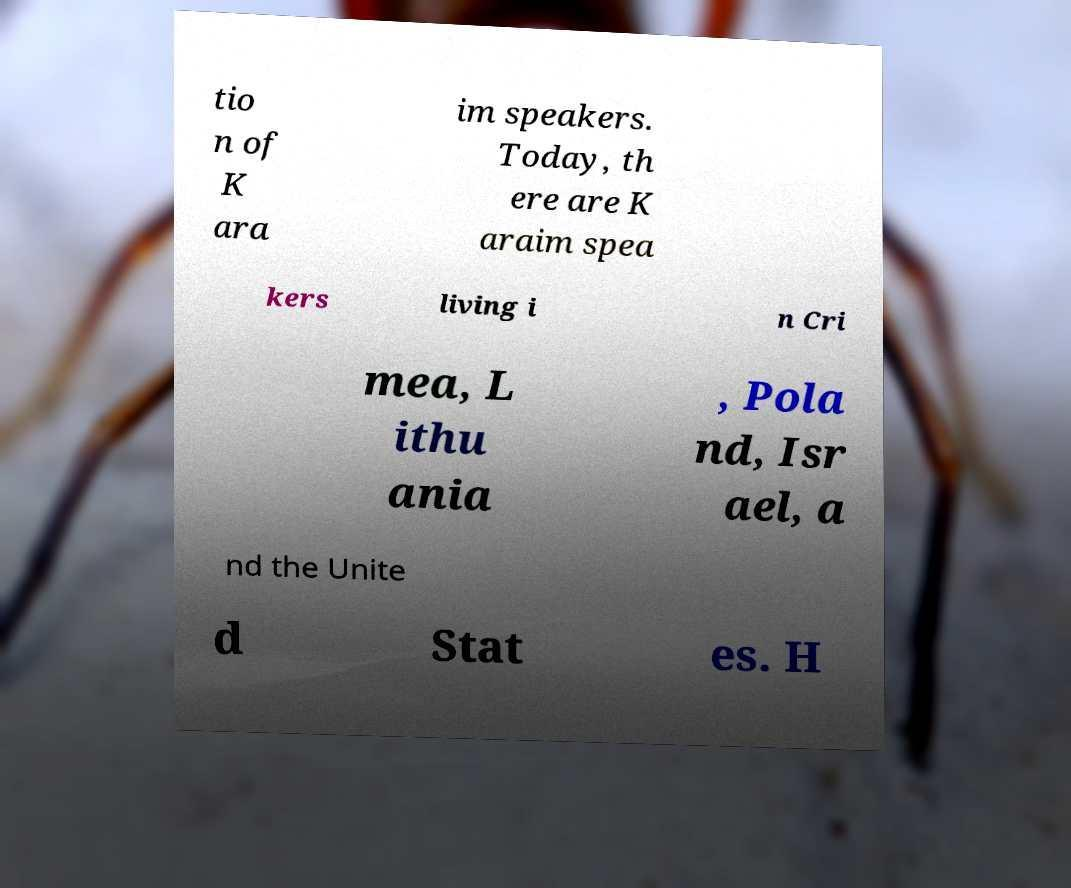Can you read and provide the text displayed in the image?This photo seems to have some interesting text. Can you extract and type it out for me? tio n of K ara im speakers. Today, th ere are K araim spea kers living i n Cri mea, L ithu ania , Pola nd, Isr ael, a nd the Unite d Stat es. H 